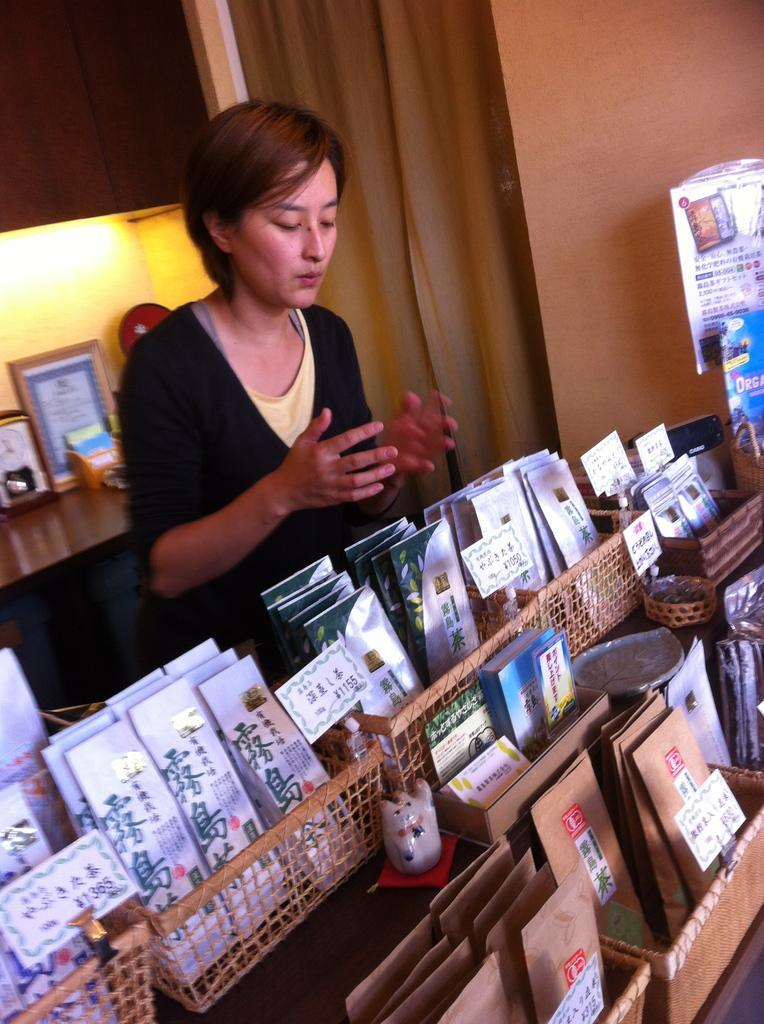Please provide a concise description of this image. In this picture there is a woman wearing black dress is standing and there are few objects in front of her which is placed in wooden boxes and there is a table behind her which has a photo frame,a clock and some other objects placed on it. 